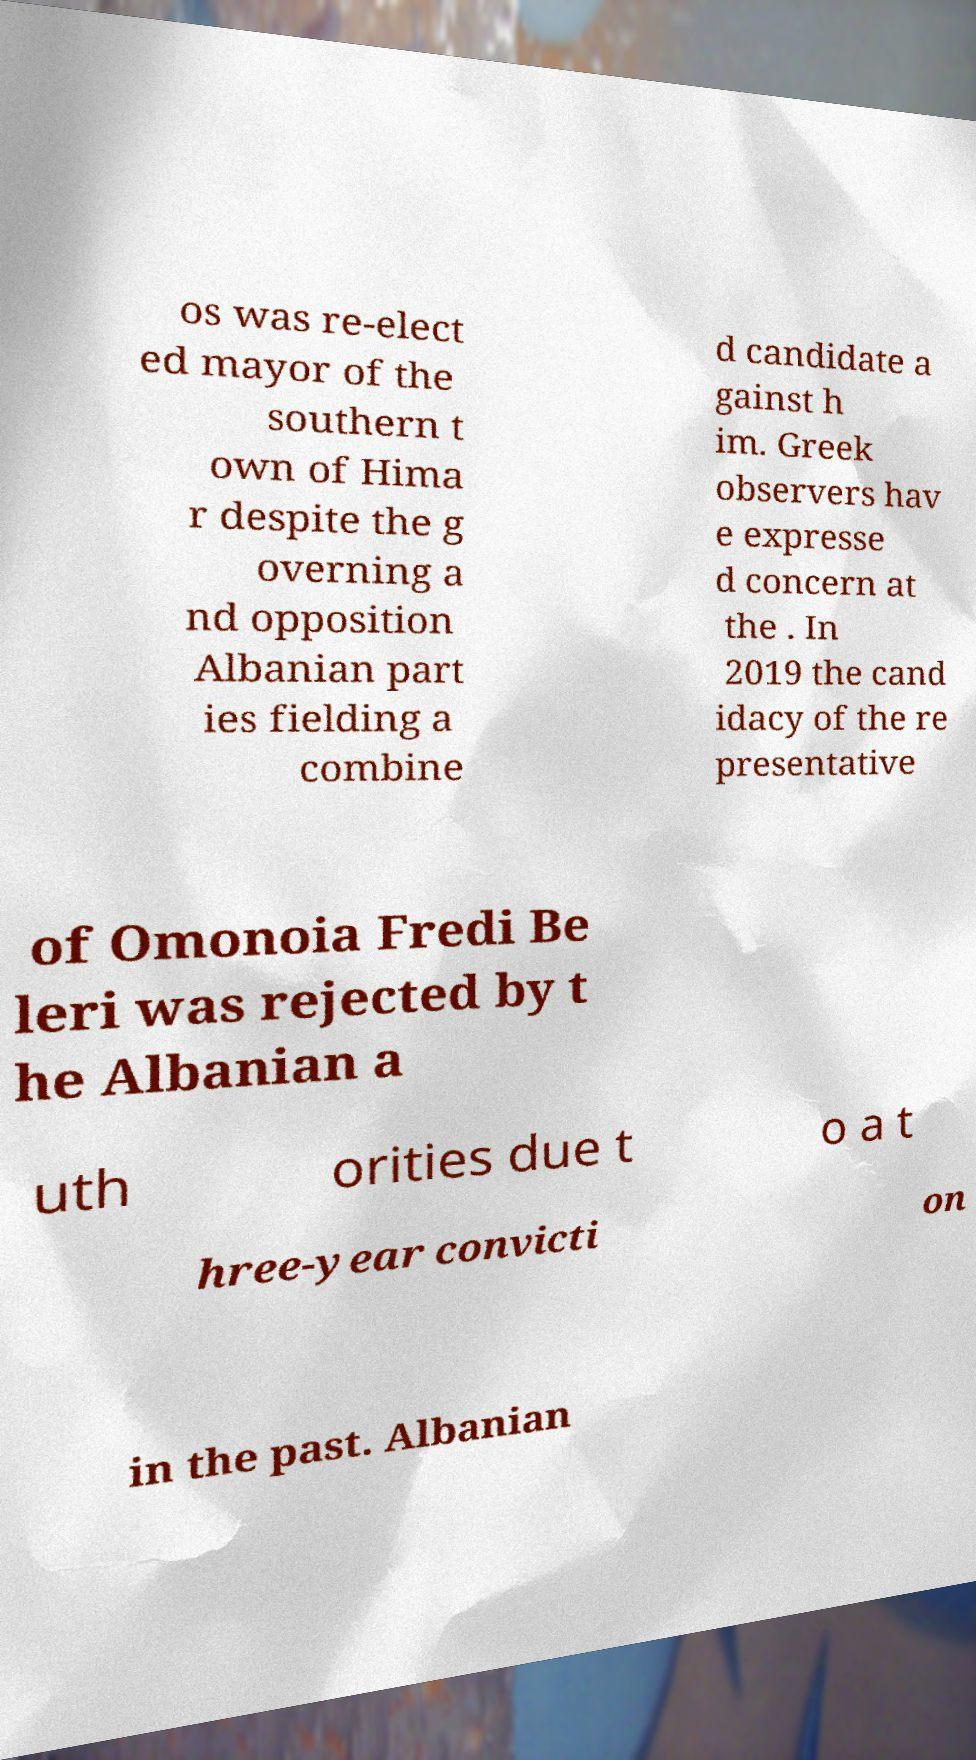Could you assist in decoding the text presented in this image and type it out clearly? os was re-elect ed mayor of the southern t own of Hima r despite the g overning a nd opposition Albanian part ies fielding a combine d candidate a gainst h im. Greek observers hav e expresse d concern at the . In 2019 the cand idacy of the re presentative of Omonoia Fredi Be leri was rejected by t he Albanian a uth orities due t o a t hree-year convicti on in the past. Albanian 